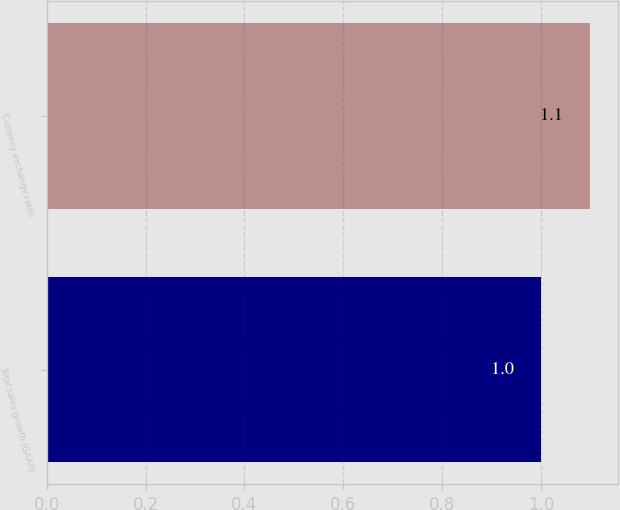<chart> <loc_0><loc_0><loc_500><loc_500><bar_chart><fcel>Total sales growth (GAAP)<fcel>Currency exchange rates<nl><fcel>1<fcel>1.1<nl></chart> 